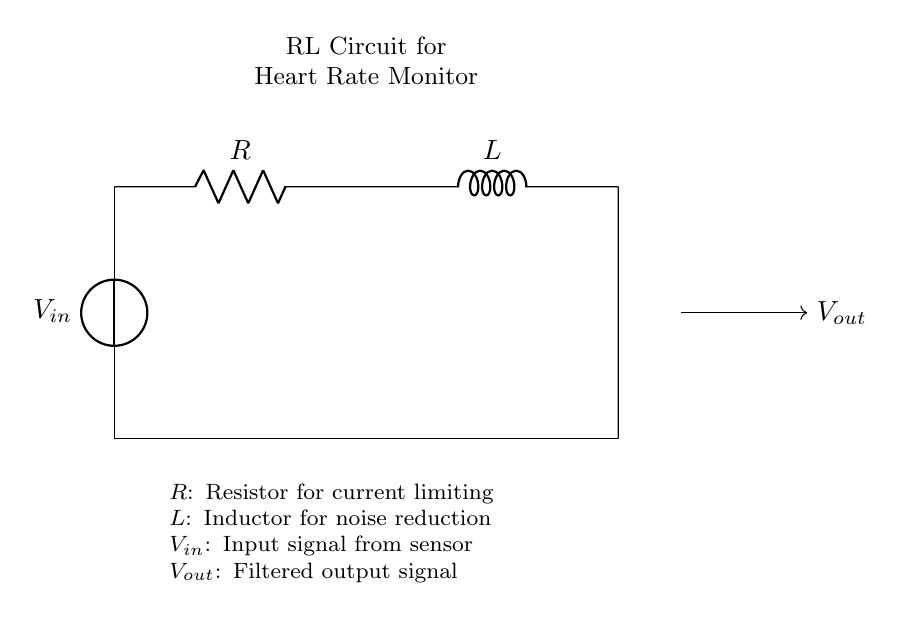What are the two main components in this circuit? The diagram explicitly labels the components as a resistor (R) and an inductor (L). These are the critical parts of an RL circuit.
Answer: R, L What is the purpose of the resistor in this circuit? The resistor is used for current limiting, as indicated in the note below the circuit. It helps control the flow of current in the circuit.
Answer: Current limiting What is the role of the inductor in this circuit? The inductor is employed for noise reduction, helping to filter out unwanted signals. The note below the circuit specifies its function clearly.
Answer: Noise reduction What is the input signal denoted by in the diagram? The input signal is represented as V sub in, which is connected on the left side of the circuit. This signals the starting point of the electrical flow.
Answer: V sub in How does the output signal relate to the input in this RL circuit? The output signal, labeled as V sub out, is connected after the resistor and inductor, indicating that it is a filtered version of the input signal.
Answer: Filtered output What happens to high-frequency noise in this RL circuit? The inductor serves to reduce high-frequency noise due to its property of opposing changes in current, thereby acting as a low-pass filter in this configuration.
Answer: Reduced What type of circuit is represented here? This circuit is identified as an RL circuit, meaning it comprises a resistor and an inductor working together for specific applications, such as filtering in heart rate monitors.
Answer: RL circuit 